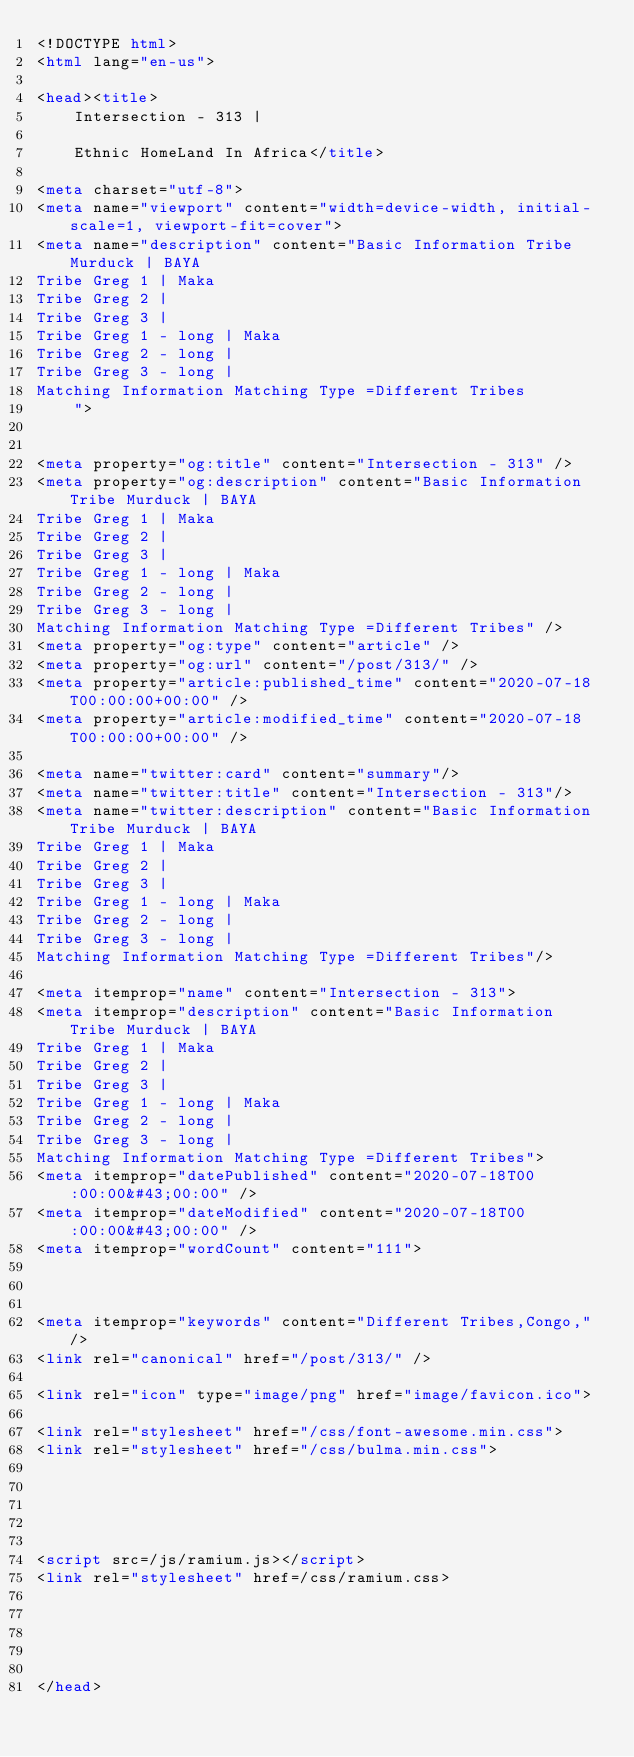<code> <loc_0><loc_0><loc_500><loc_500><_HTML_><!DOCTYPE html>
<html lang="en-us">

<head><title>
    Intersection - 313 | 
    
    Ethnic HomeLand In Africa</title>

<meta charset="utf-8">
<meta name="viewport" content="width=device-width, initial-scale=1, viewport-fit=cover">
<meta name="description" content="Basic Information Tribe Murduck | BAYA
Tribe Greg 1 | Maka
Tribe Greg 2 |
Tribe Greg 3 |
Tribe Greg 1 - long | Maka
Tribe Greg 2 - long |
Tribe Greg 3 - long |
Matching Information Matching Type =Different Tribes
    ">


<meta property="og:title" content="Intersection - 313" />
<meta property="og:description" content="Basic Information Tribe Murduck | BAYA
Tribe Greg 1 | Maka
Tribe Greg 2 |
Tribe Greg 3 |
Tribe Greg 1 - long | Maka
Tribe Greg 2 - long |
Tribe Greg 3 - long |
Matching Information Matching Type =Different Tribes" />
<meta property="og:type" content="article" />
<meta property="og:url" content="/post/313/" />
<meta property="article:published_time" content="2020-07-18T00:00:00+00:00" />
<meta property="article:modified_time" content="2020-07-18T00:00:00+00:00" />

<meta name="twitter:card" content="summary"/>
<meta name="twitter:title" content="Intersection - 313"/>
<meta name="twitter:description" content="Basic Information Tribe Murduck | BAYA
Tribe Greg 1 | Maka
Tribe Greg 2 |
Tribe Greg 3 |
Tribe Greg 1 - long | Maka
Tribe Greg 2 - long |
Tribe Greg 3 - long |
Matching Information Matching Type =Different Tribes"/>

<meta itemprop="name" content="Intersection - 313">
<meta itemprop="description" content="Basic Information Tribe Murduck | BAYA
Tribe Greg 1 | Maka
Tribe Greg 2 |
Tribe Greg 3 |
Tribe Greg 1 - long | Maka
Tribe Greg 2 - long |
Tribe Greg 3 - long |
Matching Information Matching Type =Different Tribes">
<meta itemprop="datePublished" content="2020-07-18T00:00:00&#43;00:00" />
<meta itemprop="dateModified" content="2020-07-18T00:00:00&#43;00:00" />
<meta itemprop="wordCount" content="111">



<meta itemprop="keywords" content="Different Tribes,Congo," />
<link rel="canonical" href="/post/313/" />

<link rel="icon" type="image/png" href="image/favicon.ico">

<link rel="stylesheet" href="/css/font-awesome.min.css">
<link rel="stylesheet" href="/css/bulma.min.css">





<script src=/js/ramium.js></script>
<link rel="stylesheet" href=/css/ramium.css>





</head>
</code> 